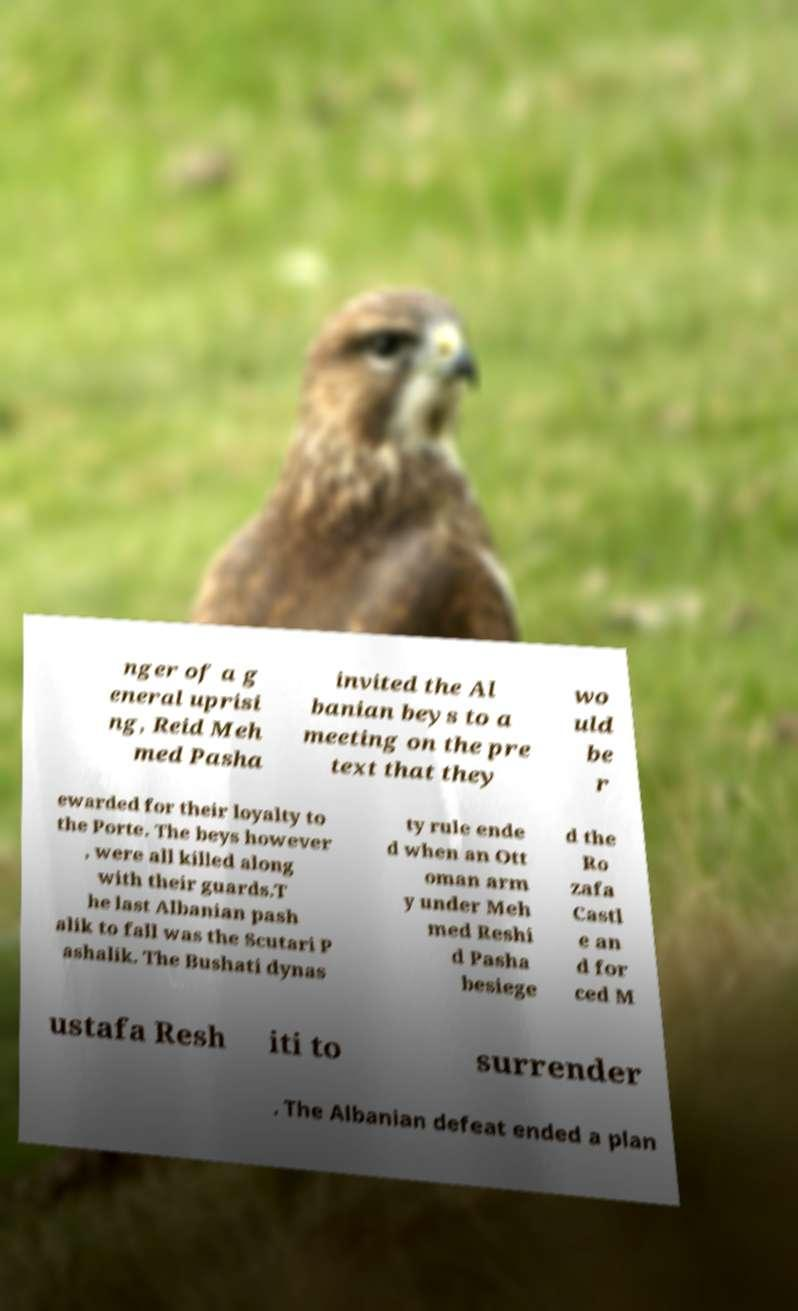Can you accurately transcribe the text from the provided image for me? nger of a g eneral uprisi ng, Reid Meh med Pasha invited the Al banian beys to a meeting on the pre text that they wo uld be r ewarded for their loyalty to the Porte. The beys however , were all killed along with their guards.T he last Albanian pash alik to fall was the Scutari P ashalik. The Bushati dynas ty rule ende d when an Ott oman arm y under Meh med Reshi d Pasha besiege d the Ro zafa Castl e an d for ced M ustafa Resh iti to surrender . The Albanian defeat ended a plan 